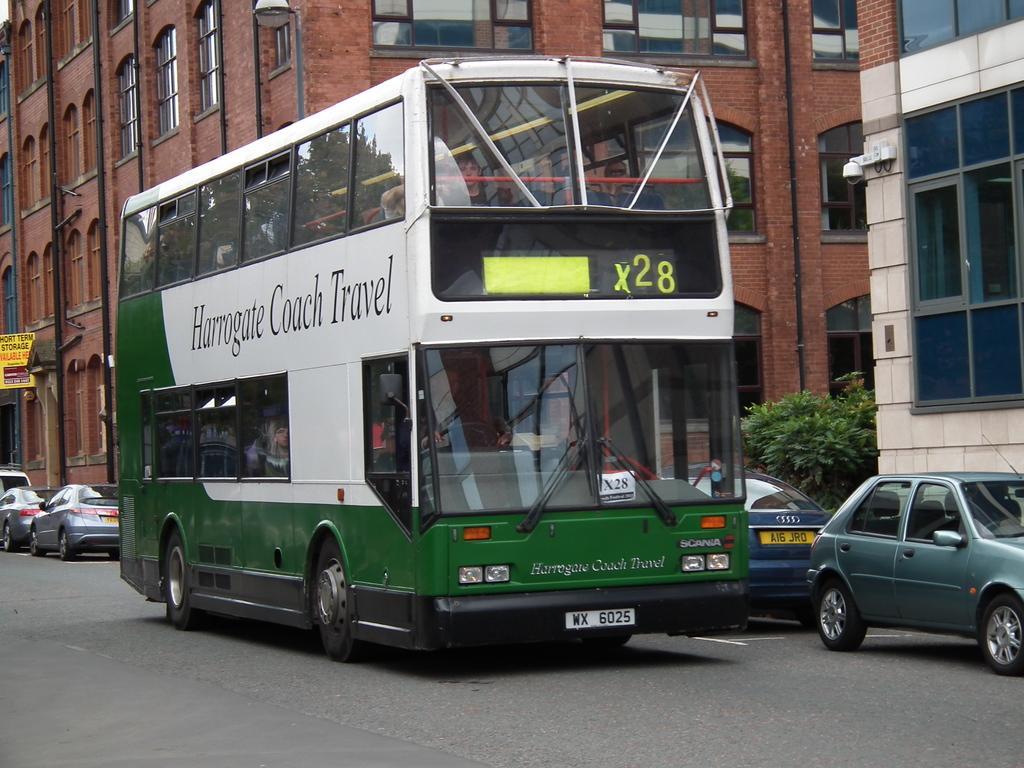How would you summarize this image in a sentence or two? In this picture i can see many peoples were sitting inside the green bus. Beside the bus I can see many cars which are parked in front of the building. On the right there is a tree near to the window and wall. At the top there is a street light. On the left i can see the posts near to the black pipes and windows. At the bottom there is a road. 